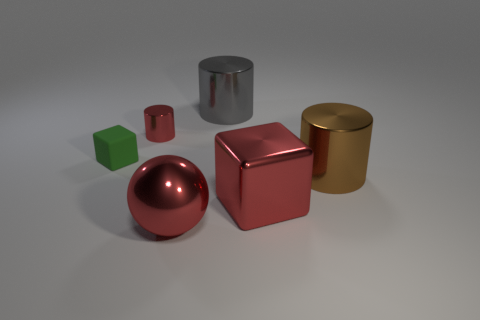There is a cylinder that is the same color as the big shiny cube; what size is it?
Offer a terse response. Small. What number of large things are the same color as the small shiny cylinder?
Your answer should be very brief. 2. What number of cylinders are either gray objects or big brown objects?
Keep it short and to the point. 2. Does the tiny shiny cylinder have the same color as the large cube?
Your answer should be very brief. Yes. Are there an equal number of spheres behind the red block and big metal things to the right of the gray metal object?
Ensure brevity in your answer.  No. What is the color of the big sphere?
Provide a short and direct response. Red. What number of things are big cylinders in front of the red cylinder or brown rubber cylinders?
Offer a terse response. 1. Does the red object left of the red ball have the same size as the cylinder behind the small red metal thing?
Your response must be concise. No. Is there anything else that is made of the same material as the tiny block?
Your response must be concise. No. What number of things are either shiny cylinders on the right side of the red metal cylinder or shiny objects behind the tiny green block?
Make the answer very short. 3. 